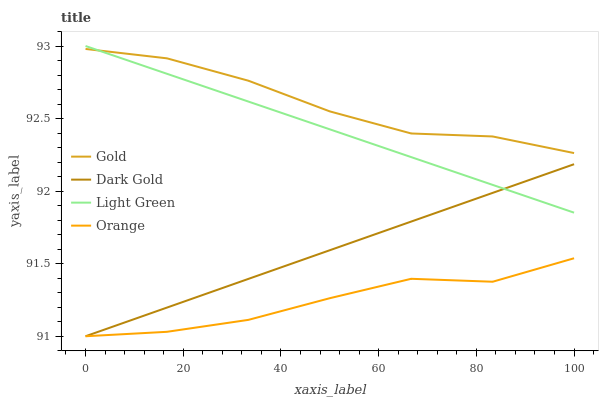Does Light Green have the minimum area under the curve?
Answer yes or no. No. Does Light Green have the maximum area under the curve?
Answer yes or no. No. Is Gold the smoothest?
Answer yes or no. No. Is Gold the roughest?
Answer yes or no. No. Does Light Green have the lowest value?
Answer yes or no. No. Does Gold have the highest value?
Answer yes or no. No. Is Dark Gold less than Gold?
Answer yes or no. Yes. Is Light Green greater than Orange?
Answer yes or no. Yes. Does Dark Gold intersect Gold?
Answer yes or no. No. 